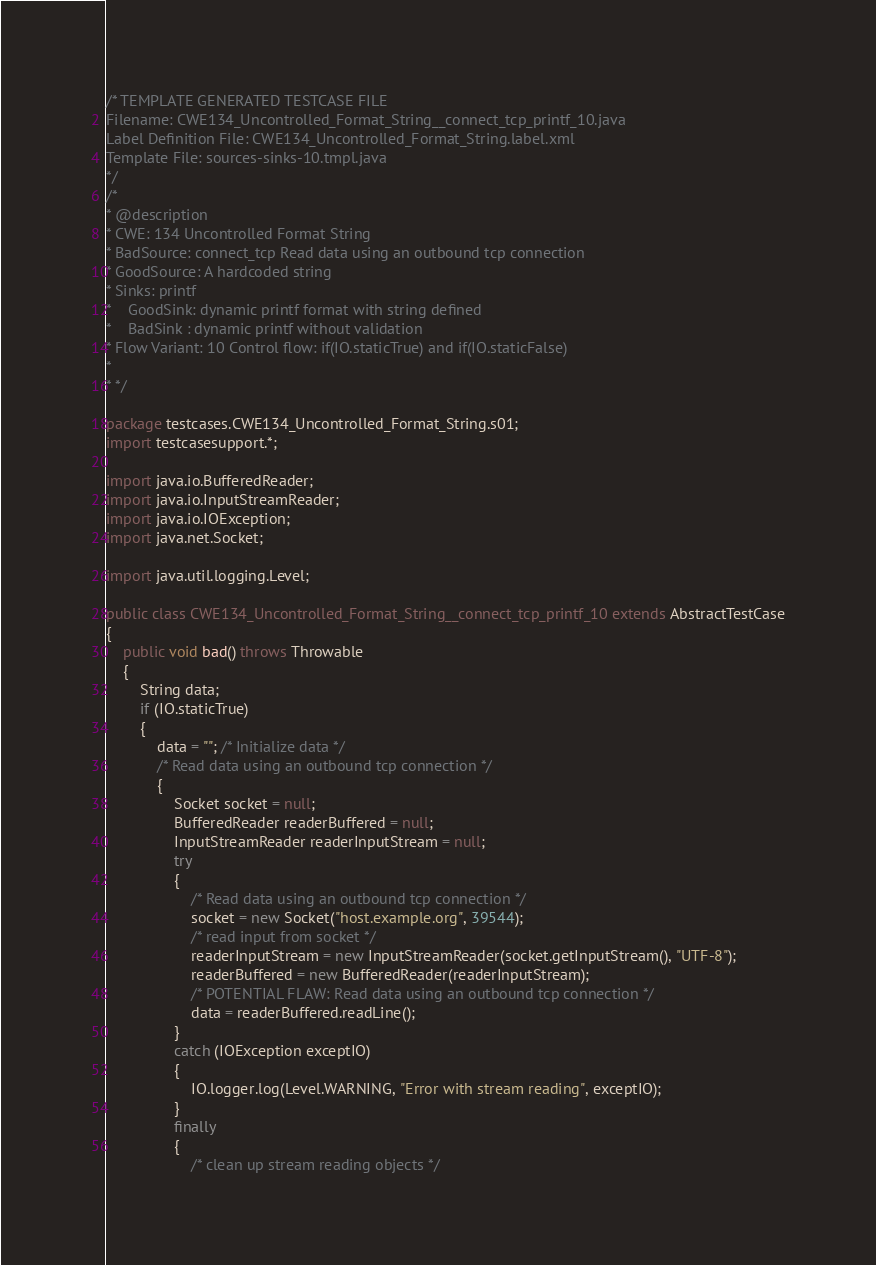Convert code to text. <code><loc_0><loc_0><loc_500><loc_500><_Java_>/* TEMPLATE GENERATED TESTCASE FILE
Filename: CWE134_Uncontrolled_Format_String__connect_tcp_printf_10.java
Label Definition File: CWE134_Uncontrolled_Format_String.label.xml
Template File: sources-sinks-10.tmpl.java
*/
/*
* @description
* CWE: 134 Uncontrolled Format String
* BadSource: connect_tcp Read data using an outbound tcp connection
* GoodSource: A hardcoded string
* Sinks: printf
*    GoodSink: dynamic printf format with string defined
*    BadSink : dynamic printf without validation
* Flow Variant: 10 Control flow: if(IO.staticTrue) and if(IO.staticFalse)
*
* */

package testcases.CWE134_Uncontrolled_Format_String.s01;
import testcasesupport.*;

import java.io.BufferedReader;
import java.io.InputStreamReader;
import java.io.IOException;
import java.net.Socket;

import java.util.logging.Level;

public class CWE134_Uncontrolled_Format_String__connect_tcp_printf_10 extends AbstractTestCase
{
    public void bad() throws Throwable
    {
        String data;
        if (IO.staticTrue)
        {
            data = ""; /* Initialize data */
            /* Read data using an outbound tcp connection */
            {
                Socket socket = null;
                BufferedReader readerBuffered = null;
                InputStreamReader readerInputStream = null;
                try
                {
                    /* Read data using an outbound tcp connection */
                    socket = new Socket("host.example.org", 39544);
                    /* read input from socket */
                    readerInputStream = new InputStreamReader(socket.getInputStream(), "UTF-8");
                    readerBuffered = new BufferedReader(readerInputStream);
                    /* POTENTIAL FLAW: Read data using an outbound tcp connection */
                    data = readerBuffered.readLine();
                }
                catch (IOException exceptIO)
                {
                    IO.logger.log(Level.WARNING, "Error with stream reading", exceptIO);
                }
                finally
                {
                    /* clean up stream reading objects */</code> 